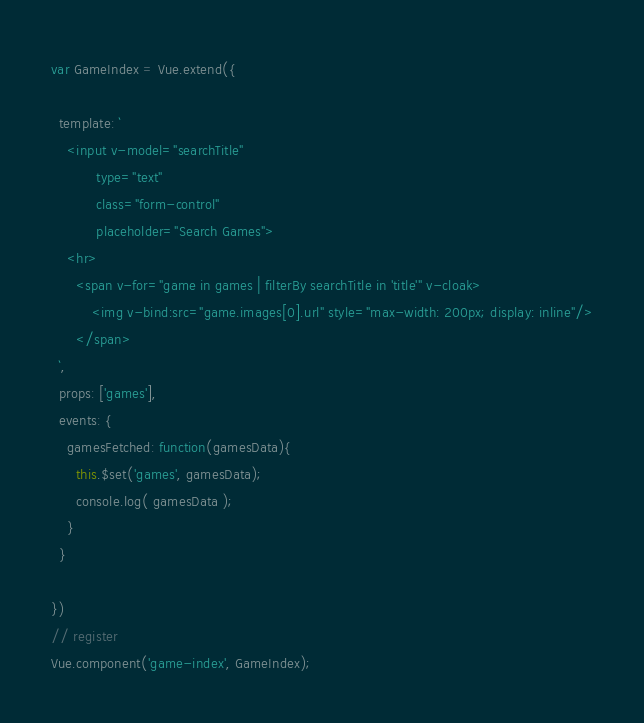<code> <loc_0><loc_0><loc_500><loc_500><_JavaScript_>var GameIndex = Vue.extend({

  template: `
    <input v-model="searchTitle"
           type="text"
           class="form-control"
           placeholder="Search Games">
    <hr>
      <span v-for="game in games | filterBy searchTitle in 'title'" v-cloak>
          <img v-bind:src="game.images[0].url" style="max-width: 200px; display: inline"/>
      </span>
  `,
  props: ['games'],
  events: {
    gamesFetched: function(gamesData){
      this.$set('games', gamesData);
      console.log( gamesData );
    }
  }

})
// register
Vue.component('game-index', GameIndex);</code> 